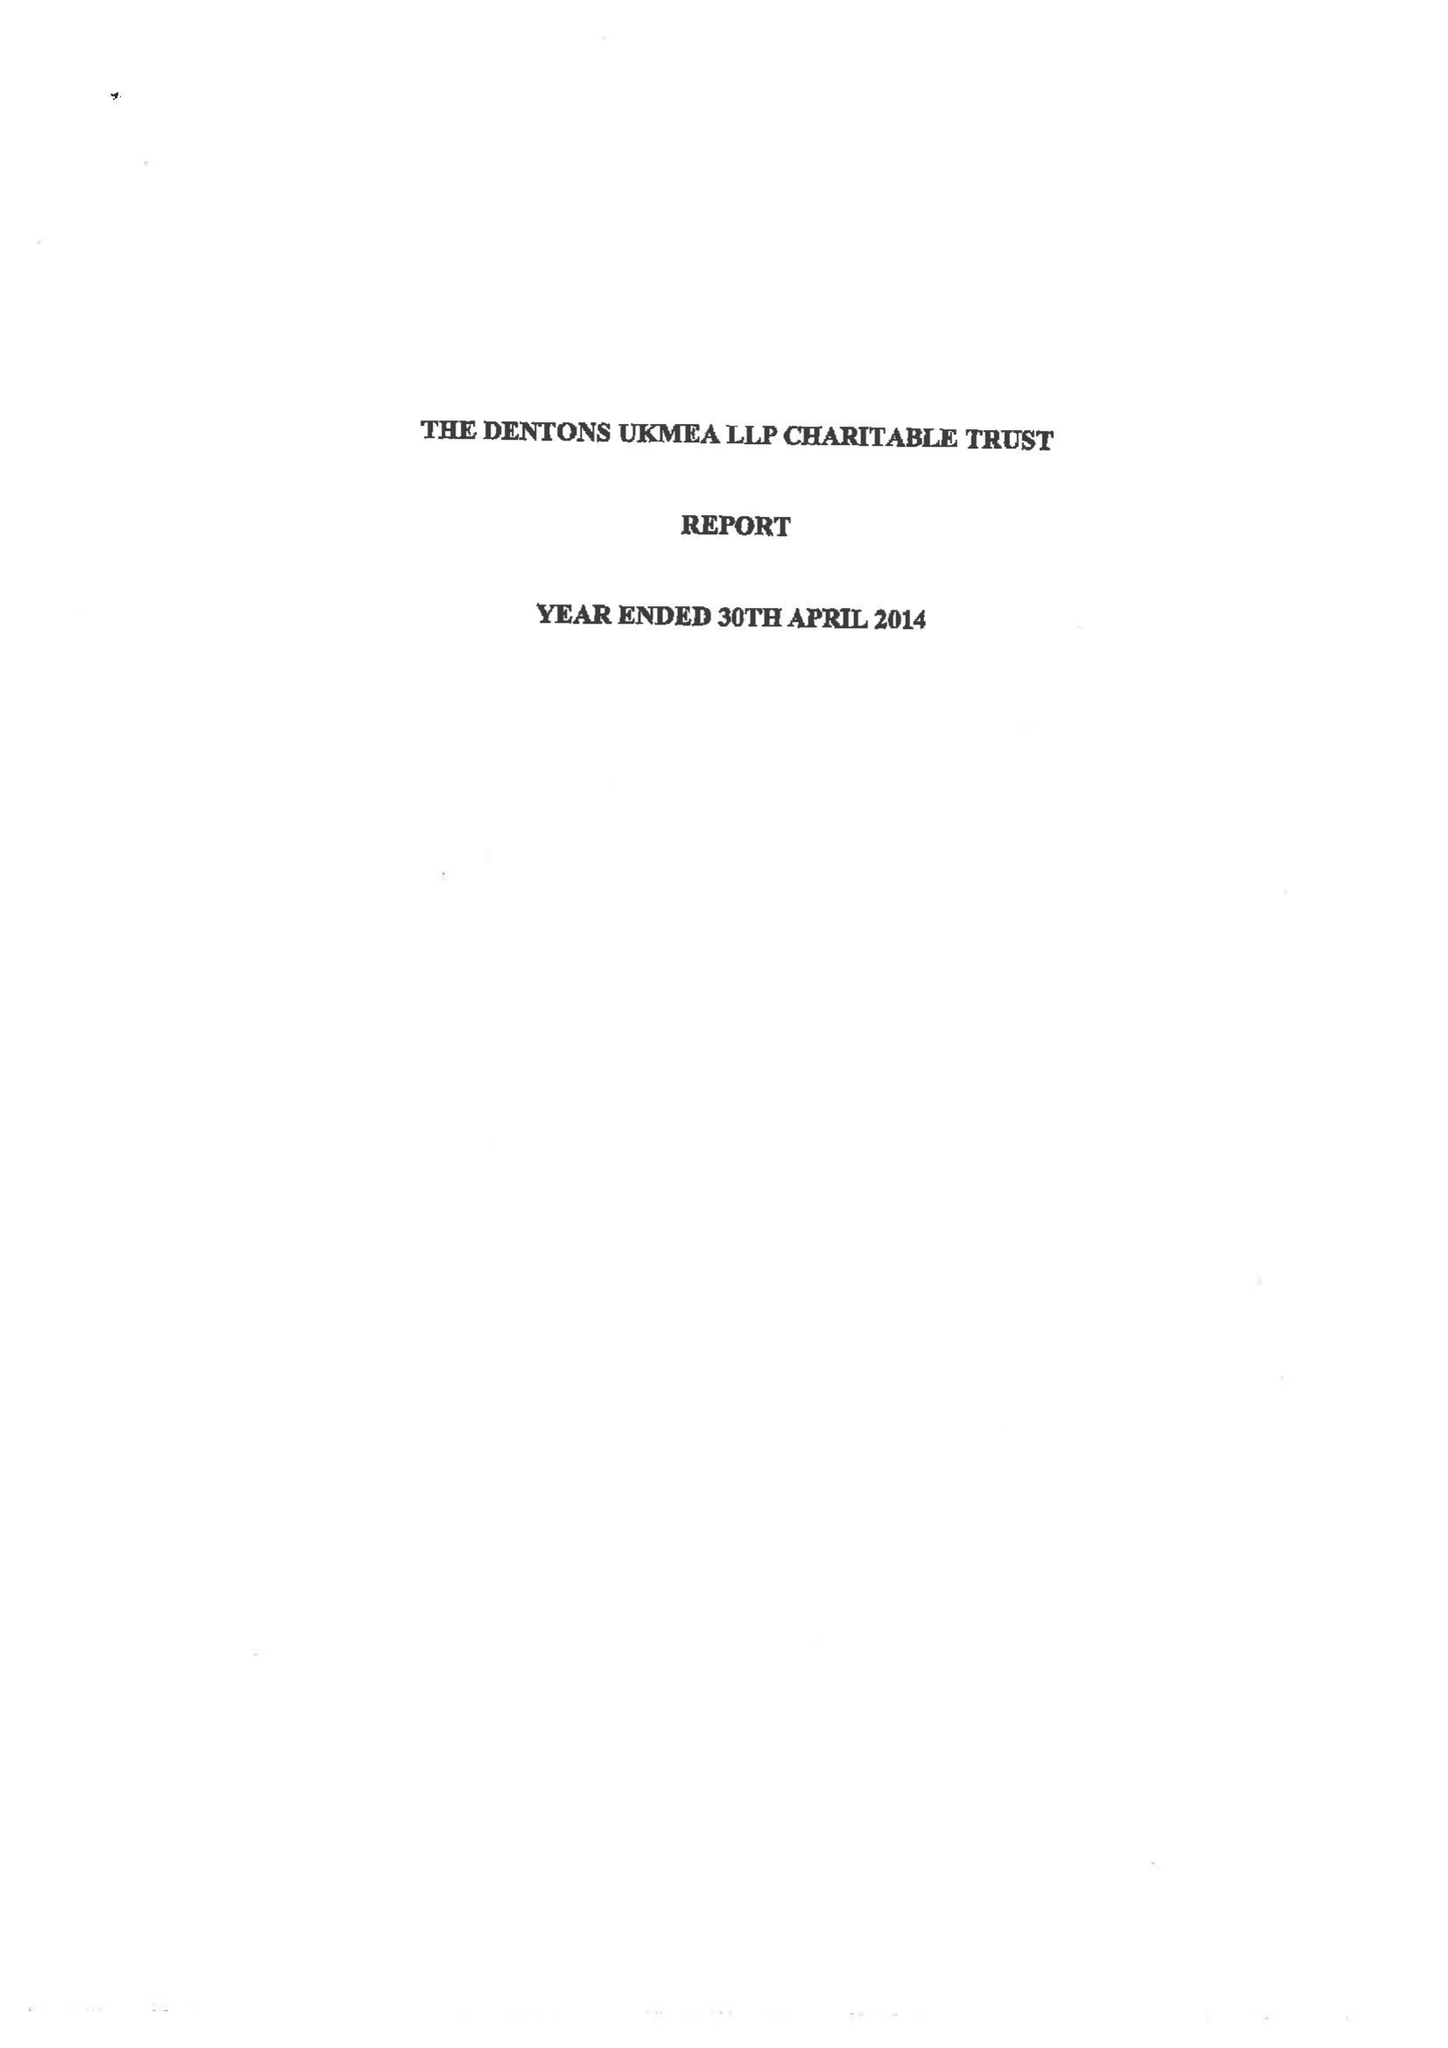What is the value for the spending_annually_in_british_pounds?
Answer the question using a single word or phrase. 90167.00 